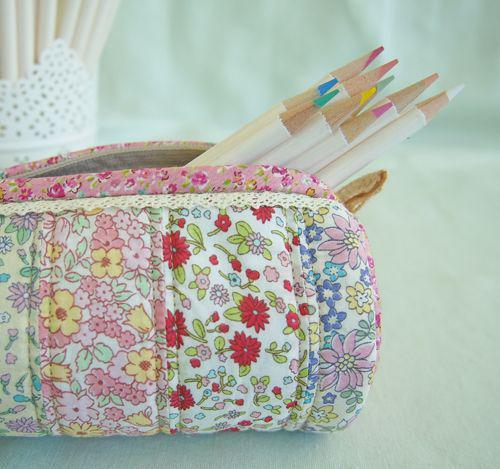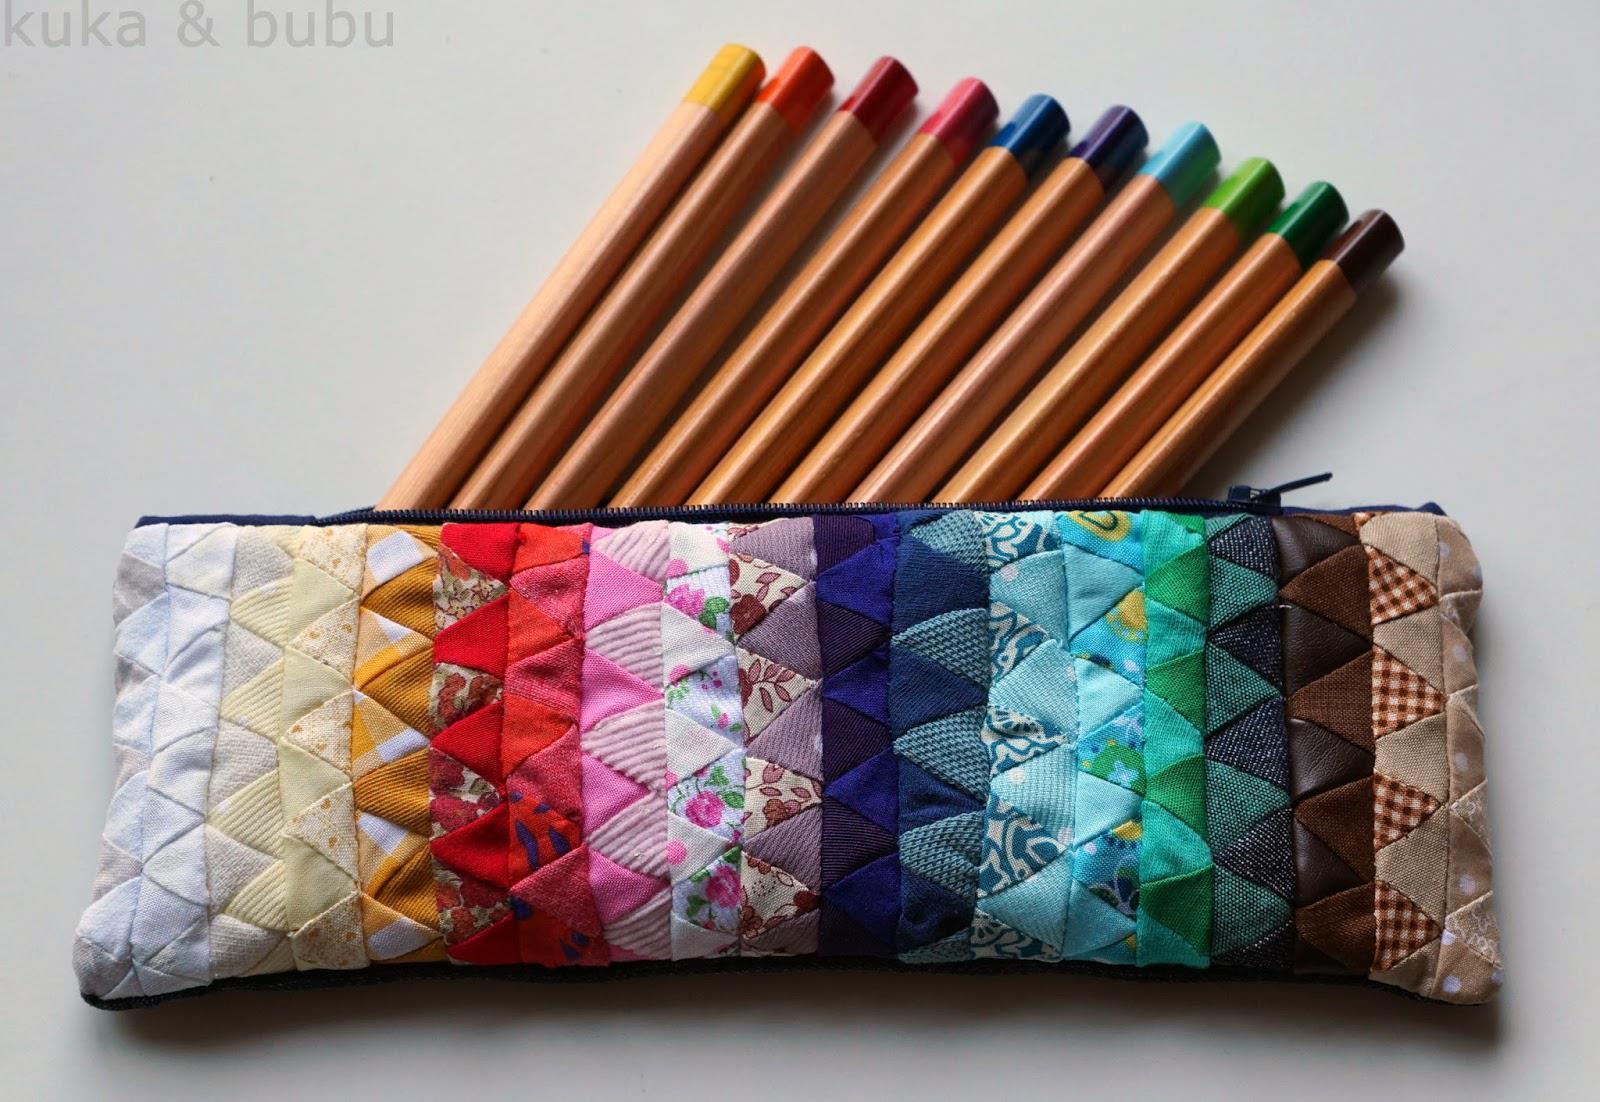The first image is the image on the left, the second image is the image on the right. Analyze the images presented: Is the assertion "One image shows two tube-shaped zipper cases with patchwork patterns displayed end-first, and the other image shows one flat zipper case with a patterned exterior." valid? Answer yes or no. No. The first image is the image on the left, the second image is the image on the right. Considering the images on both sides, is "Exactly one pouch is open with office supplies sticking out." valid? Answer yes or no. No. 